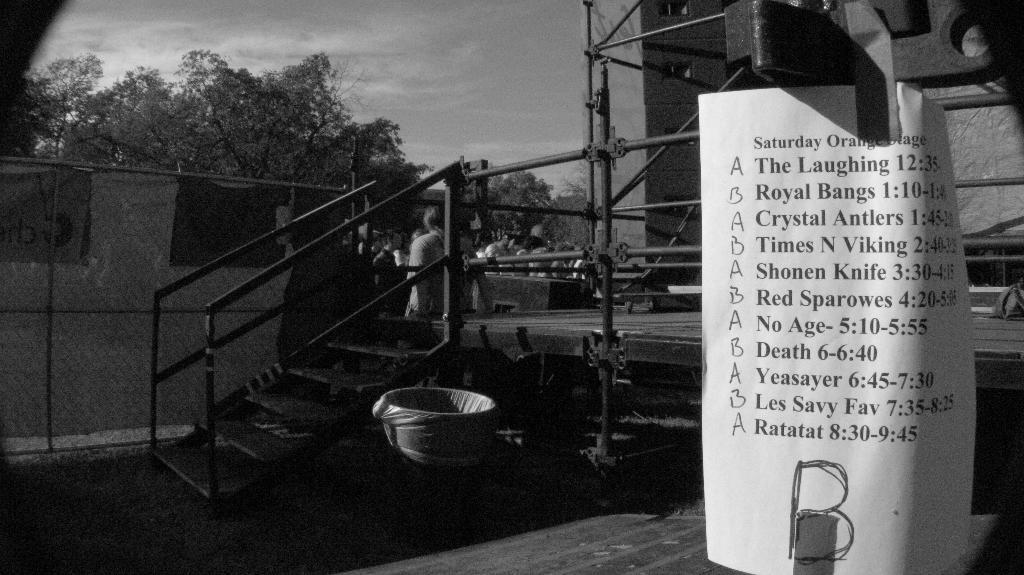In one or two sentences, can you explain what this image depicts? This image is clicked outside. On the right, there is a paper fixed to the pole. In the middle, there is a tub. Beside that there are stairs. On the left, there is a tent. In the background, there are trees. 